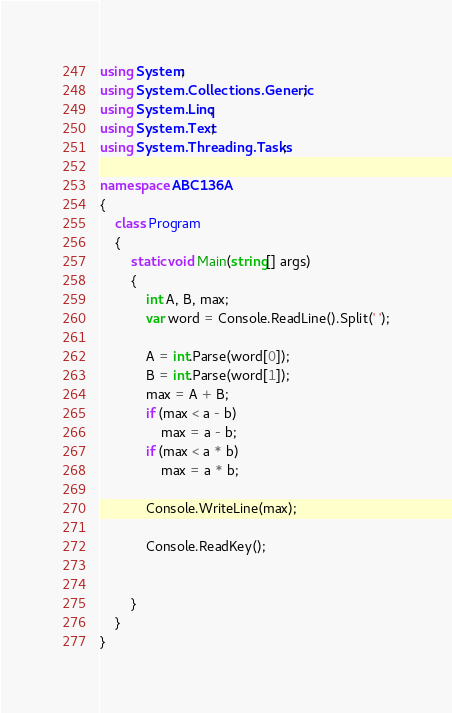<code> <loc_0><loc_0><loc_500><loc_500><_C#_>using System;
using System.Collections.Generic;
using System.Linq;
using System.Text;
using System.Threading.Tasks;

namespace ABC136A
{
    class Program
    {
        static void Main(string[] args)
        {
            int A, B, max;
            var word = Console.ReadLine().Split(' ');

            A = int.Parse(word[0]);
            B = int.Parse(word[1]);
            max = A + B;
            if (max < a - b)
                max = a - b;
            if (max < a * b)
                max = a * b;

            Console.WriteLine(max);

            Console.ReadKey();


        }
    }
}
</code> 